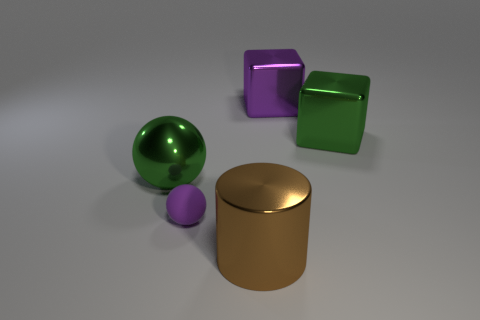How many large yellow matte balls are there?
Ensure brevity in your answer.  0. What number of things are shiny objects that are behind the purple matte sphere or large metallic spheres?
Your answer should be compact. 3. Do the large thing on the left side of the brown cylinder and the matte ball have the same color?
Provide a short and direct response. No. What number of other objects are the same color as the big shiny sphere?
Offer a very short reply. 1. What number of large things are purple metal blocks or green blocks?
Give a very brief answer. 2. Is the number of big cylinders greater than the number of tiny green objects?
Your response must be concise. Yes. Does the brown cylinder have the same material as the big ball?
Your response must be concise. Yes. Is there anything else that has the same material as the purple ball?
Provide a succinct answer. No. Is the number of small purple rubber objects behind the big green cube greater than the number of small things?
Provide a succinct answer. No. Does the small thing have the same color as the shiny ball?
Ensure brevity in your answer.  No. 